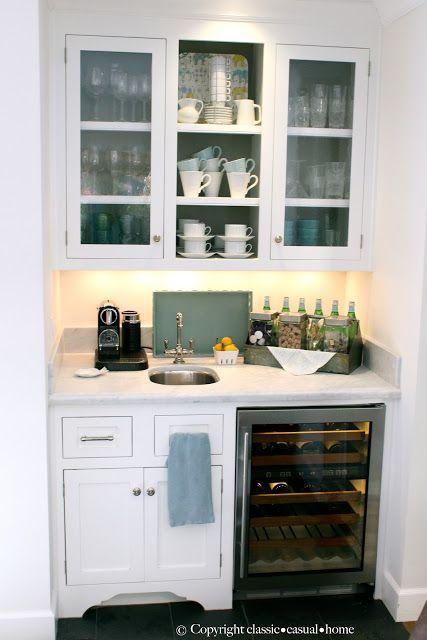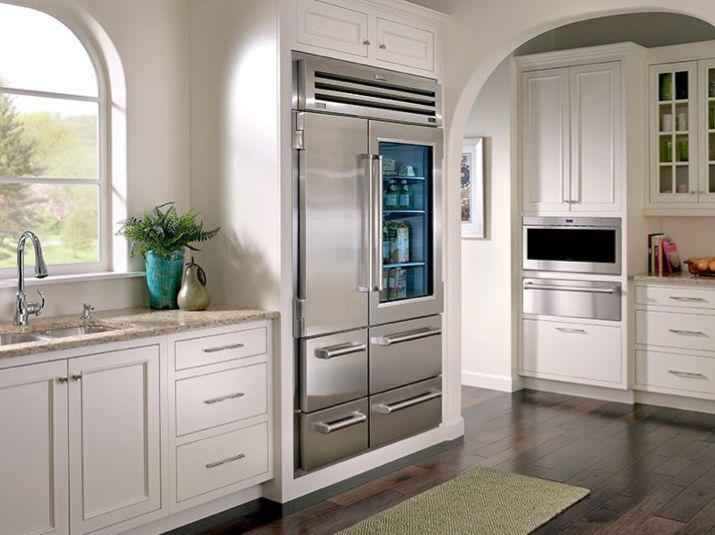The first image is the image on the left, the second image is the image on the right. For the images displayed, is the sentence "There is a stainless steel refrigerator  next to an entryway." factually correct? Answer yes or no. Yes. 